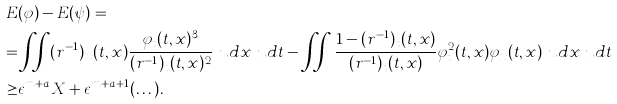Convert formula to latex. <formula><loc_0><loc_0><loc_500><loc_500>E & ( \varphi ) - E ( \psi ) = \\ = & \iint ( r ^ { - 1 } ) _ { x } ( t , x ) \frac { \varphi _ { t } ( t , x ) ^ { 3 } } { ( r ^ { - 1 } ) _ { t } ( t , x ) ^ { 2 } } \ u d x \ u d t - \iint \frac { 1 - ( r ^ { - 1 } ) _ { t } ( t , x ) } { ( r ^ { - 1 } ) _ { t } ( t , x ) } \varphi ^ { 2 } _ { t } ( t , x ) \varphi _ { x } ( t , x ) \ u d x \ u d t \\ \geq & \epsilon ^ { m + a } X + \epsilon ^ { m + a + 1 } ( \dots ) .</formula> 